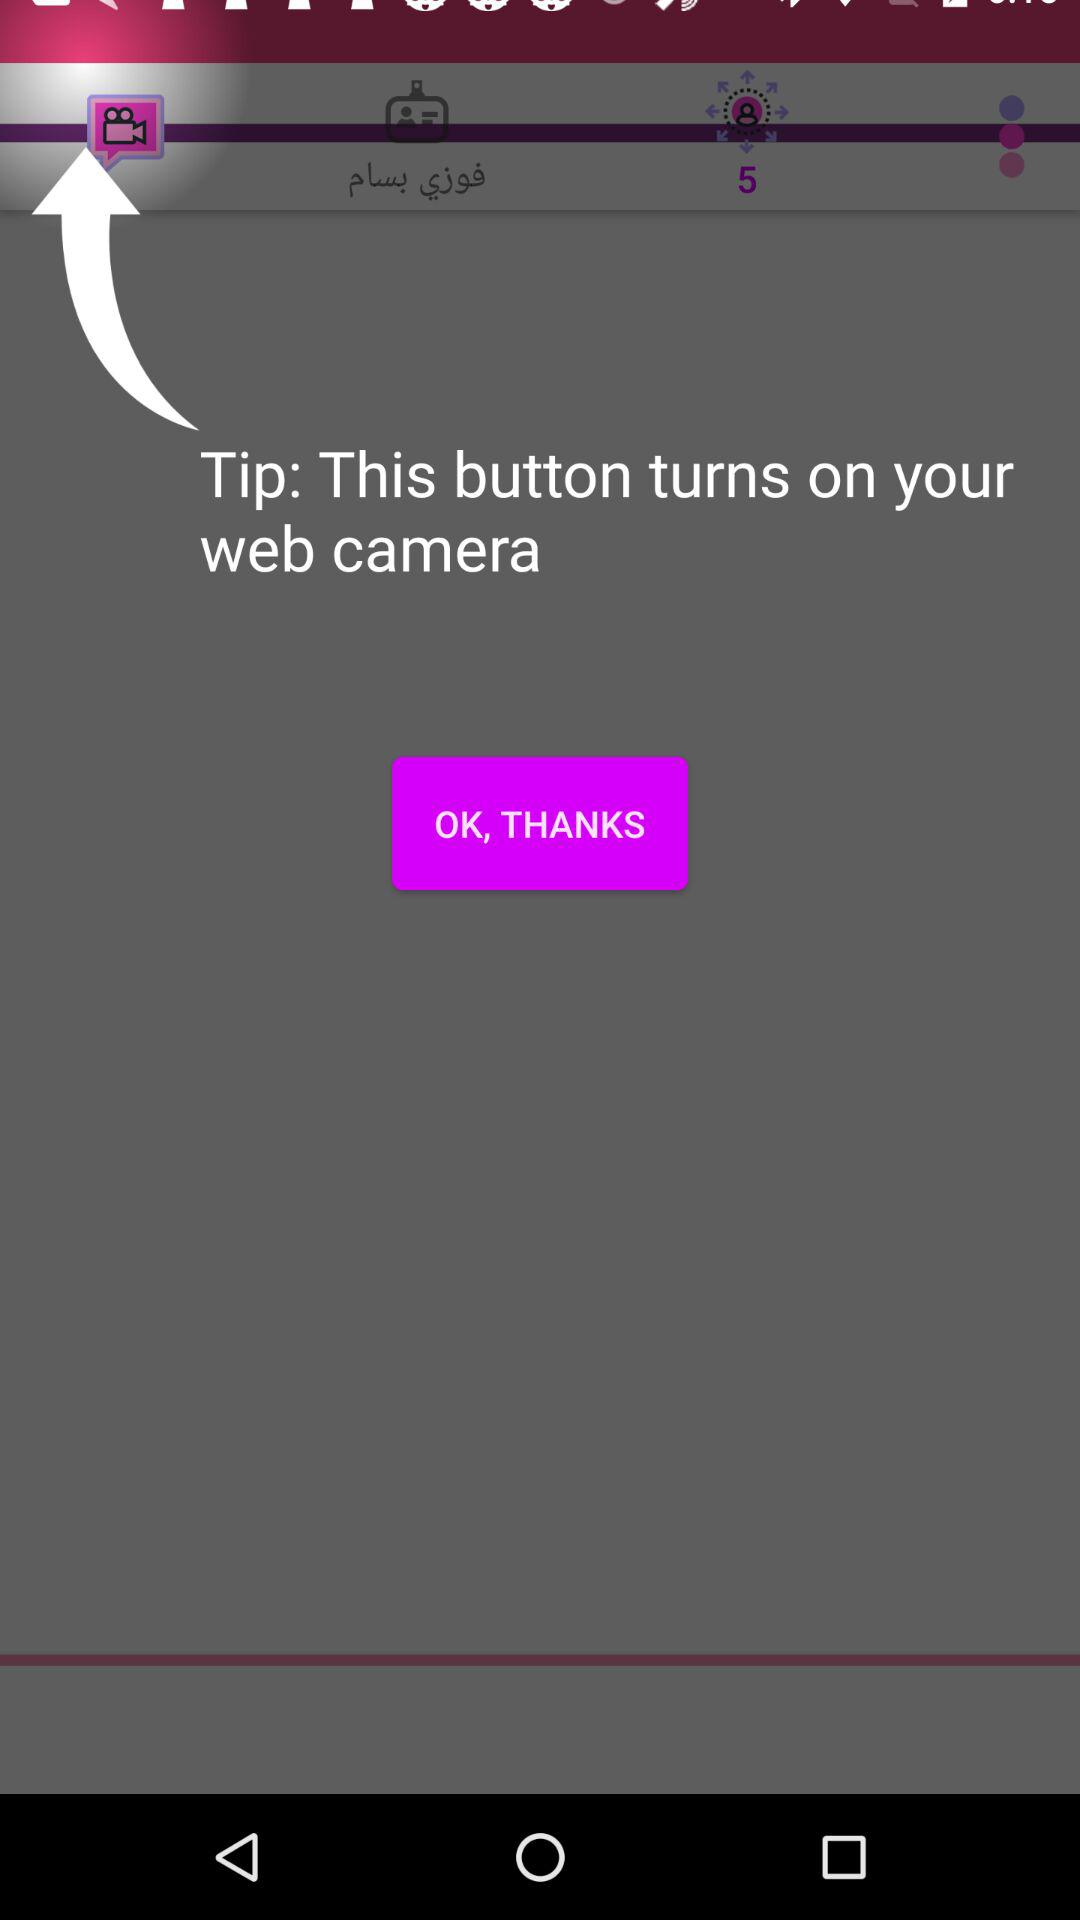How to turn the camera?
When the provided information is insufficient, respond with <no answer>. <no answer> 